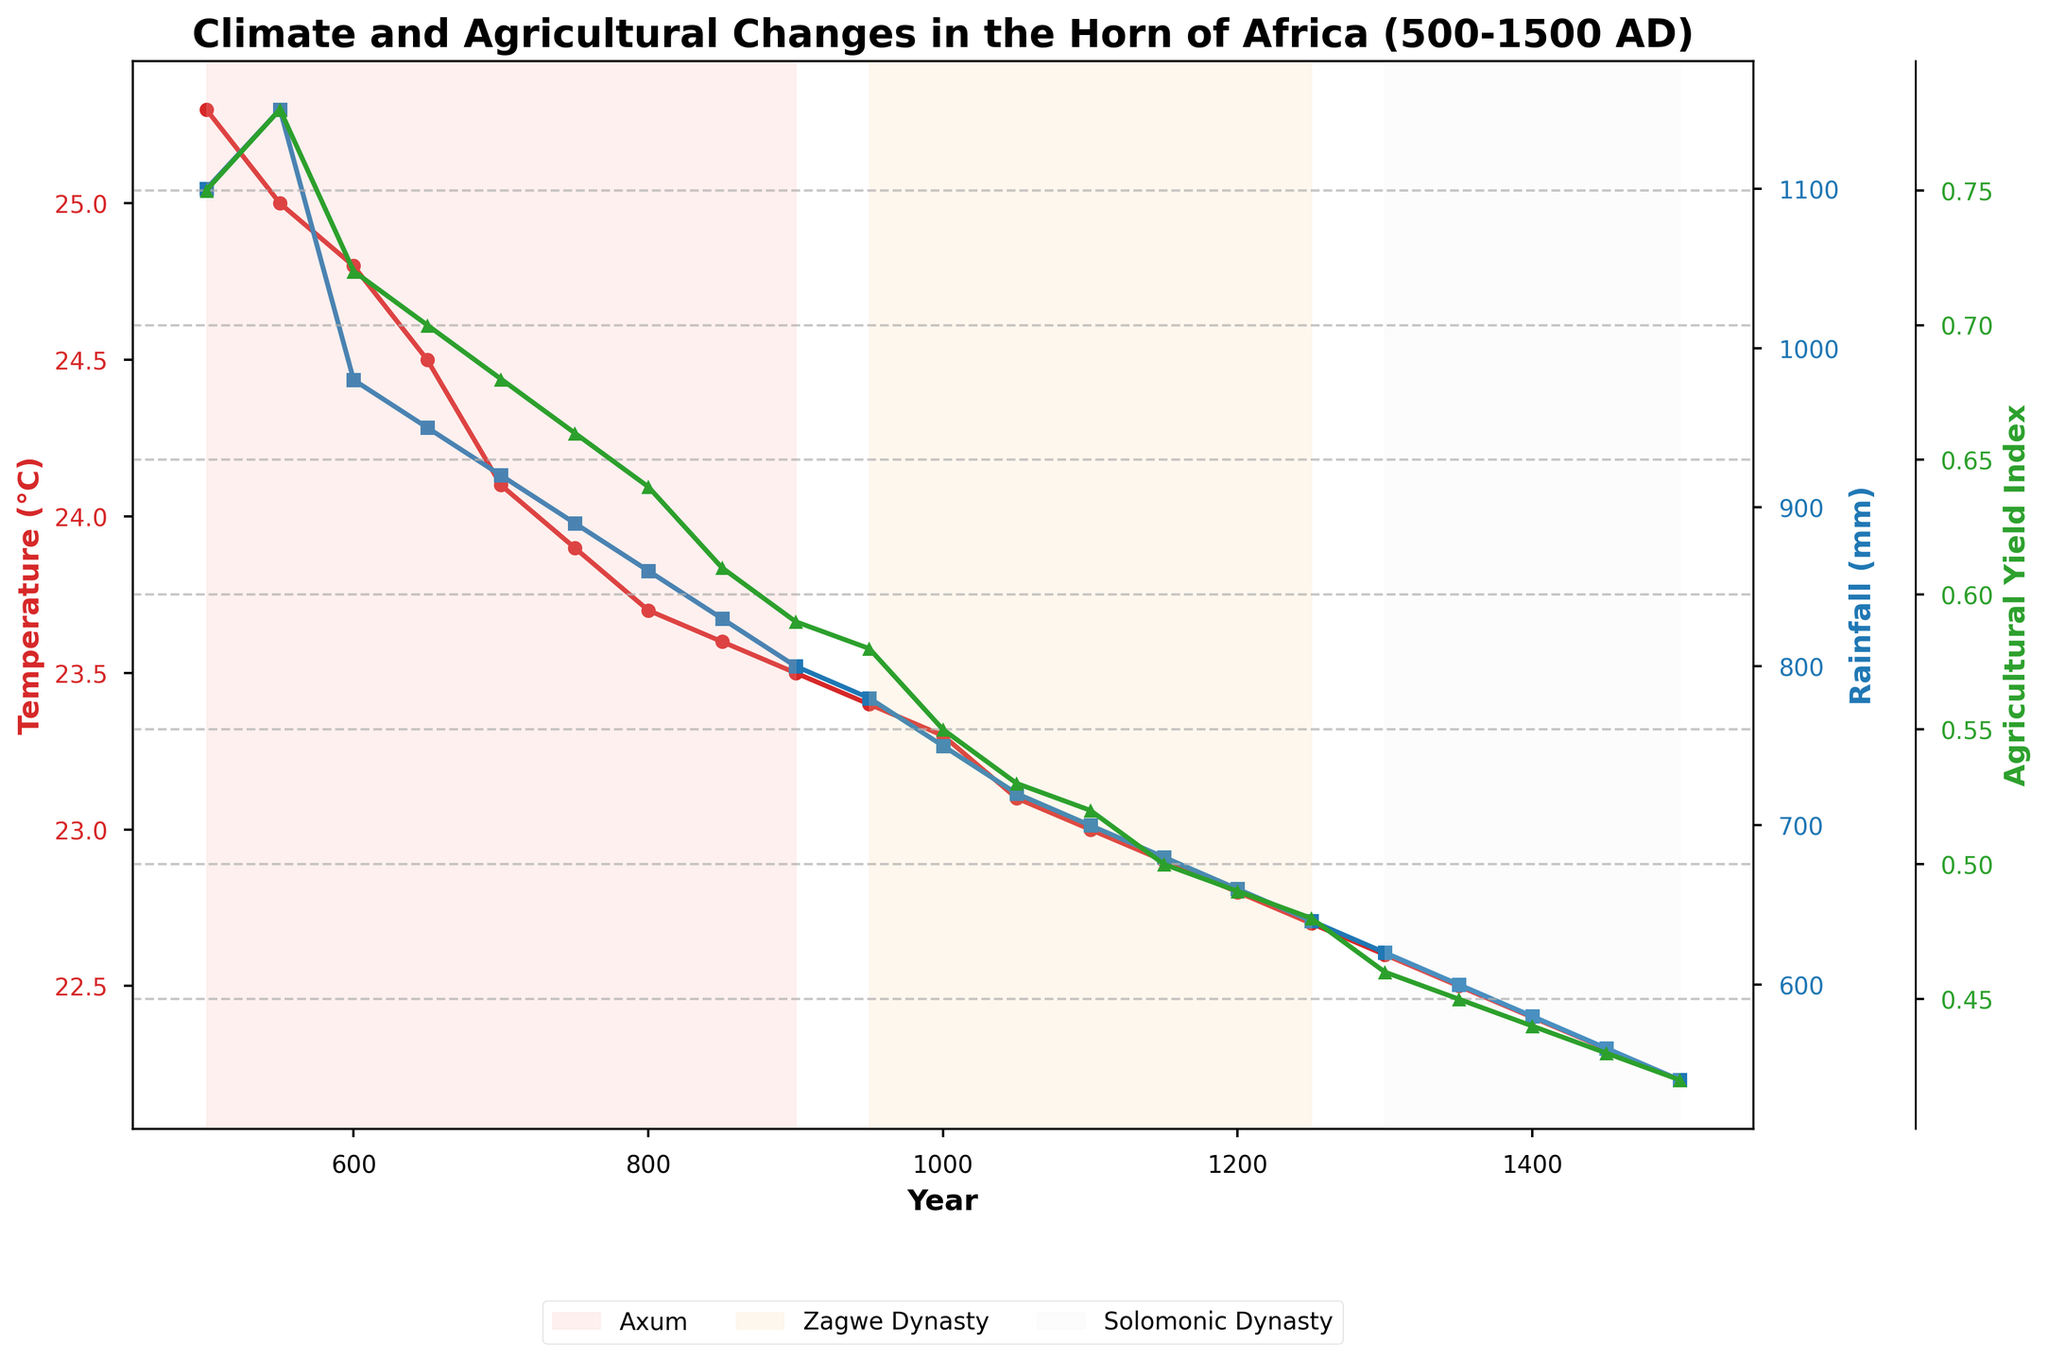What is the title of the figure? The title is usually located at the top of the figure. It provides a brief description of what the chart depicts. In this case, it indicates the topic and the timeframe covered by the data.
Answer: 'Climate and Agricultural Changes in the Horn of Africa (500-1500 AD)' What are the three variables plotted on the figure? This figure includes three different y-axes with labels that provide the names of each variable being tracked. They are color-coded to match the lines in the plot.
Answer: Average Temperature (°C), Rainfall (mm), Agricultural Yield Index Which kingdom does the plot start with and in which year? The plot uses shaded vertical regions to indicate different kingdoms. The first shaded region starts at the first data point on the x-axis.
Answer: Axum in 500 AD How has the average temperature changed from 750 AD to 1250 AD? To determine this, check the y-axis values for the Average Temperature (°C) at 750 AD and 1250 AD, and compare them.
Answer: It decreased from 23.9°C to 22.7°C Which kingdom experienced the lowest level of rainfall and in what year? To find this, examine the lowest point on the rainfall (mm) graph and see which kingdom's vertical shaded region this point falls into.
Answer: Solomonic Dynasty in 1500 AD What was the Agricultural Yield Index around 1000 AD and how does it compare to 500 AD? Locate the points at 1000 AD and 500 AD on the Agricultural Yield Index graph, then compare their y-values.
Answer: It was 0.55 in 1000 AD and 0.75 in 500 AD, indicating a decline Compare the trends in average temperature and rainfall from 500 AD to 1500 AD. Observe the overall direction of the lines representing average temperature and rainfall over the entire time period and describe their trends.
Answer: Both declined over the period During which kingdom did we notice the sharpest drop in the Agricultural Yield Index? Look for the steepest downward slope in the Agricultural Yield Index and see which kingdom's shaded region corresponds to this slope.
Answer: Axum What was the approximate average temperature during the reign of the Zagwe Dynasty? Identify the time period covered by the Zagwe Dynasty and find the average of the temperature values within this range.
Answer: Approximately 23.05°C Which variable shows the most significant decline over the entire period from 500 AD to 1500 AD? Compare the slopes of the three lines from start (500 AD) to end (1500 AD), and see which one dropped the most significantly.
Answer: Rainfall (mm) 